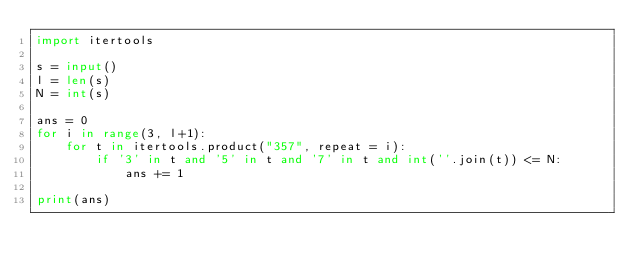Convert code to text. <code><loc_0><loc_0><loc_500><loc_500><_Python_>import itertools

s = input()
l = len(s)
N = int(s)

ans = 0
for i in range(3, l+1):
    for t in itertools.product("357", repeat = i):   
        if '3' in t and '5' in t and '7' in t and int(''.join(t)) <= N:
            ans += 1

print(ans)
</code> 